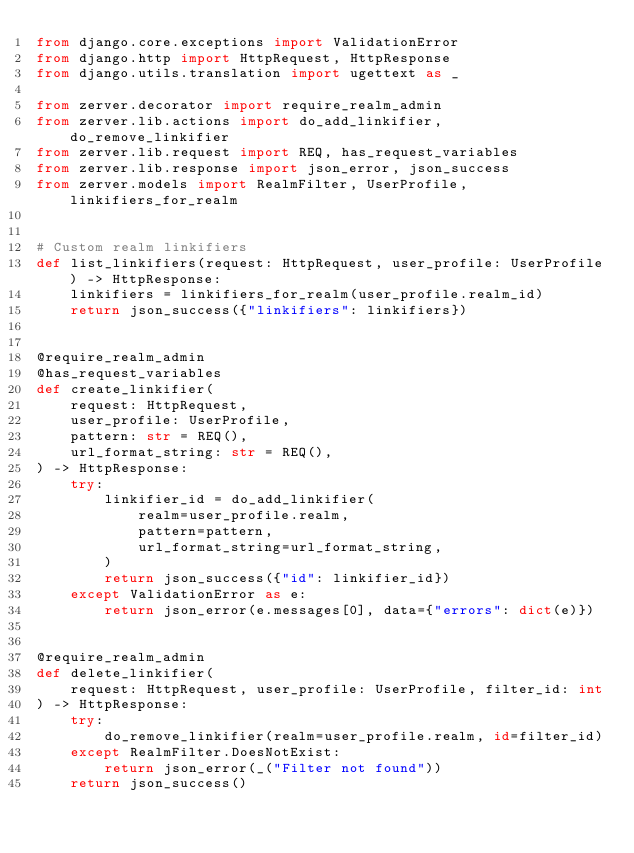<code> <loc_0><loc_0><loc_500><loc_500><_Python_>from django.core.exceptions import ValidationError
from django.http import HttpRequest, HttpResponse
from django.utils.translation import ugettext as _

from zerver.decorator import require_realm_admin
from zerver.lib.actions import do_add_linkifier, do_remove_linkifier
from zerver.lib.request import REQ, has_request_variables
from zerver.lib.response import json_error, json_success
from zerver.models import RealmFilter, UserProfile, linkifiers_for_realm


# Custom realm linkifiers
def list_linkifiers(request: HttpRequest, user_profile: UserProfile) -> HttpResponse:
    linkifiers = linkifiers_for_realm(user_profile.realm_id)
    return json_success({"linkifiers": linkifiers})


@require_realm_admin
@has_request_variables
def create_linkifier(
    request: HttpRequest,
    user_profile: UserProfile,
    pattern: str = REQ(),
    url_format_string: str = REQ(),
) -> HttpResponse:
    try:
        linkifier_id = do_add_linkifier(
            realm=user_profile.realm,
            pattern=pattern,
            url_format_string=url_format_string,
        )
        return json_success({"id": linkifier_id})
    except ValidationError as e:
        return json_error(e.messages[0], data={"errors": dict(e)})


@require_realm_admin
def delete_linkifier(
    request: HttpRequest, user_profile: UserProfile, filter_id: int
) -> HttpResponse:
    try:
        do_remove_linkifier(realm=user_profile.realm, id=filter_id)
    except RealmFilter.DoesNotExist:
        return json_error(_("Filter not found"))
    return json_success()
</code> 